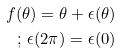Convert formula to latex. <formula><loc_0><loc_0><loc_500><loc_500>f ( \theta ) = \theta + \epsilon ( \theta ) \\ ; \, \epsilon ( 2 \pi ) = \epsilon ( 0 )</formula> 